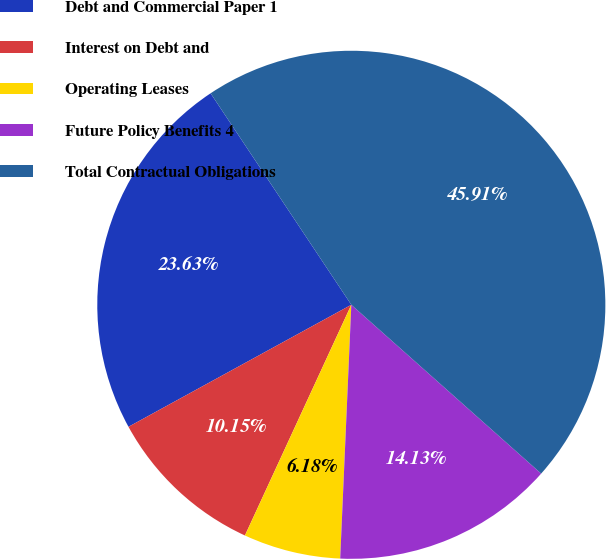Convert chart. <chart><loc_0><loc_0><loc_500><loc_500><pie_chart><fcel>Debt and Commercial Paper 1<fcel>Interest on Debt and<fcel>Operating Leases<fcel>Future Policy Benefits 4<fcel>Total Contractual Obligations<nl><fcel>23.63%<fcel>10.15%<fcel>6.18%<fcel>14.13%<fcel>45.91%<nl></chart> 